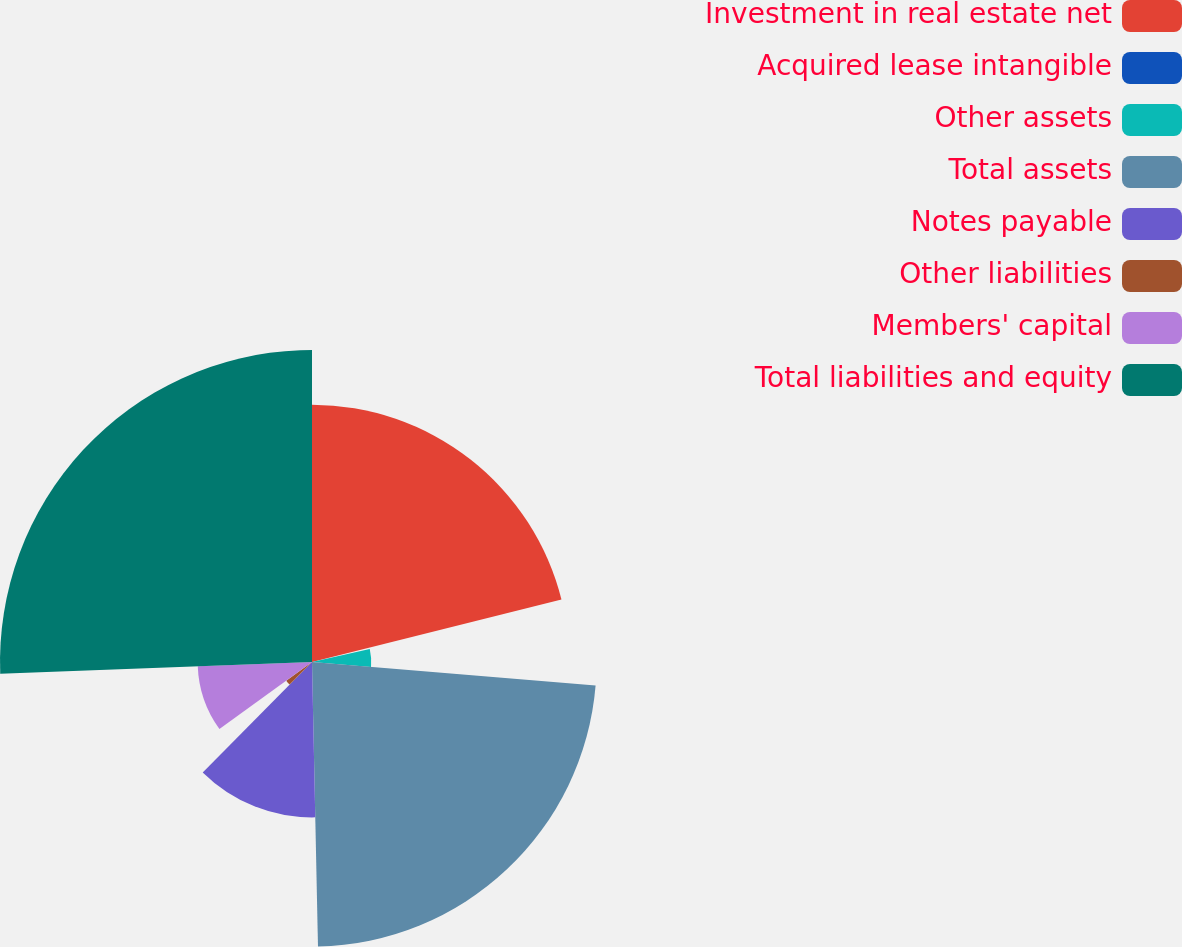Convert chart to OTSL. <chart><loc_0><loc_0><loc_500><loc_500><pie_chart><fcel>Investment in real estate net<fcel>Acquired lease intangible<fcel>Other assets<fcel>Total assets<fcel>Notes payable<fcel>Other liabilities<fcel>Members' capital<fcel>Total liabilities and equity<nl><fcel>21.1%<fcel>0.36%<fcel>4.86%<fcel>23.35%<fcel>12.75%<fcel>2.61%<fcel>9.38%<fcel>25.6%<nl></chart> 